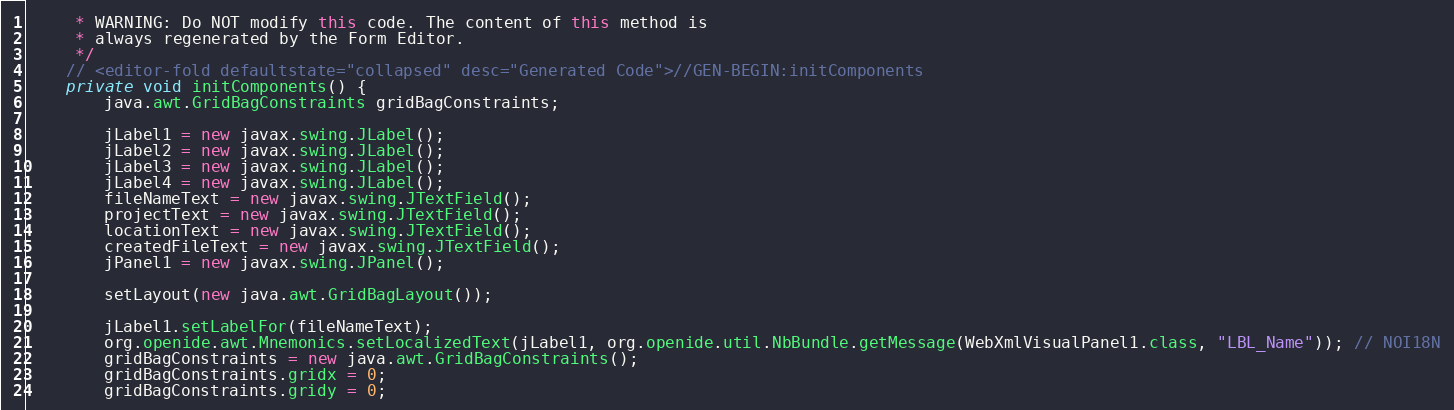<code> <loc_0><loc_0><loc_500><loc_500><_Java_>     * WARNING: Do NOT modify this code. The content of this method is
     * always regenerated by the Form Editor.
     */
    // <editor-fold defaultstate="collapsed" desc="Generated Code">//GEN-BEGIN:initComponents
    private void initComponents() {
        java.awt.GridBagConstraints gridBagConstraints;

        jLabel1 = new javax.swing.JLabel();
        jLabel2 = new javax.swing.JLabel();
        jLabel3 = new javax.swing.JLabel();
        jLabel4 = new javax.swing.JLabel();
        fileNameText = new javax.swing.JTextField();
        projectText = new javax.swing.JTextField();
        locationText = new javax.swing.JTextField();
        createdFileText = new javax.swing.JTextField();
        jPanel1 = new javax.swing.JPanel();

        setLayout(new java.awt.GridBagLayout());

        jLabel1.setLabelFor(fileNameText);
        org.openide.awt.Mnemonics.setLocalizedText(jLabel1, org.openide.util.NbBundle.getMessage(WebXmlVisualPanel1.class, "LBL_Name")); // NOI18N
        gridBagConstraints = new java.awt.GridBagConstraints();
        gridBagConstraints.gridx = 0;
        gridBagConstraints.gridy = 0;</code> 